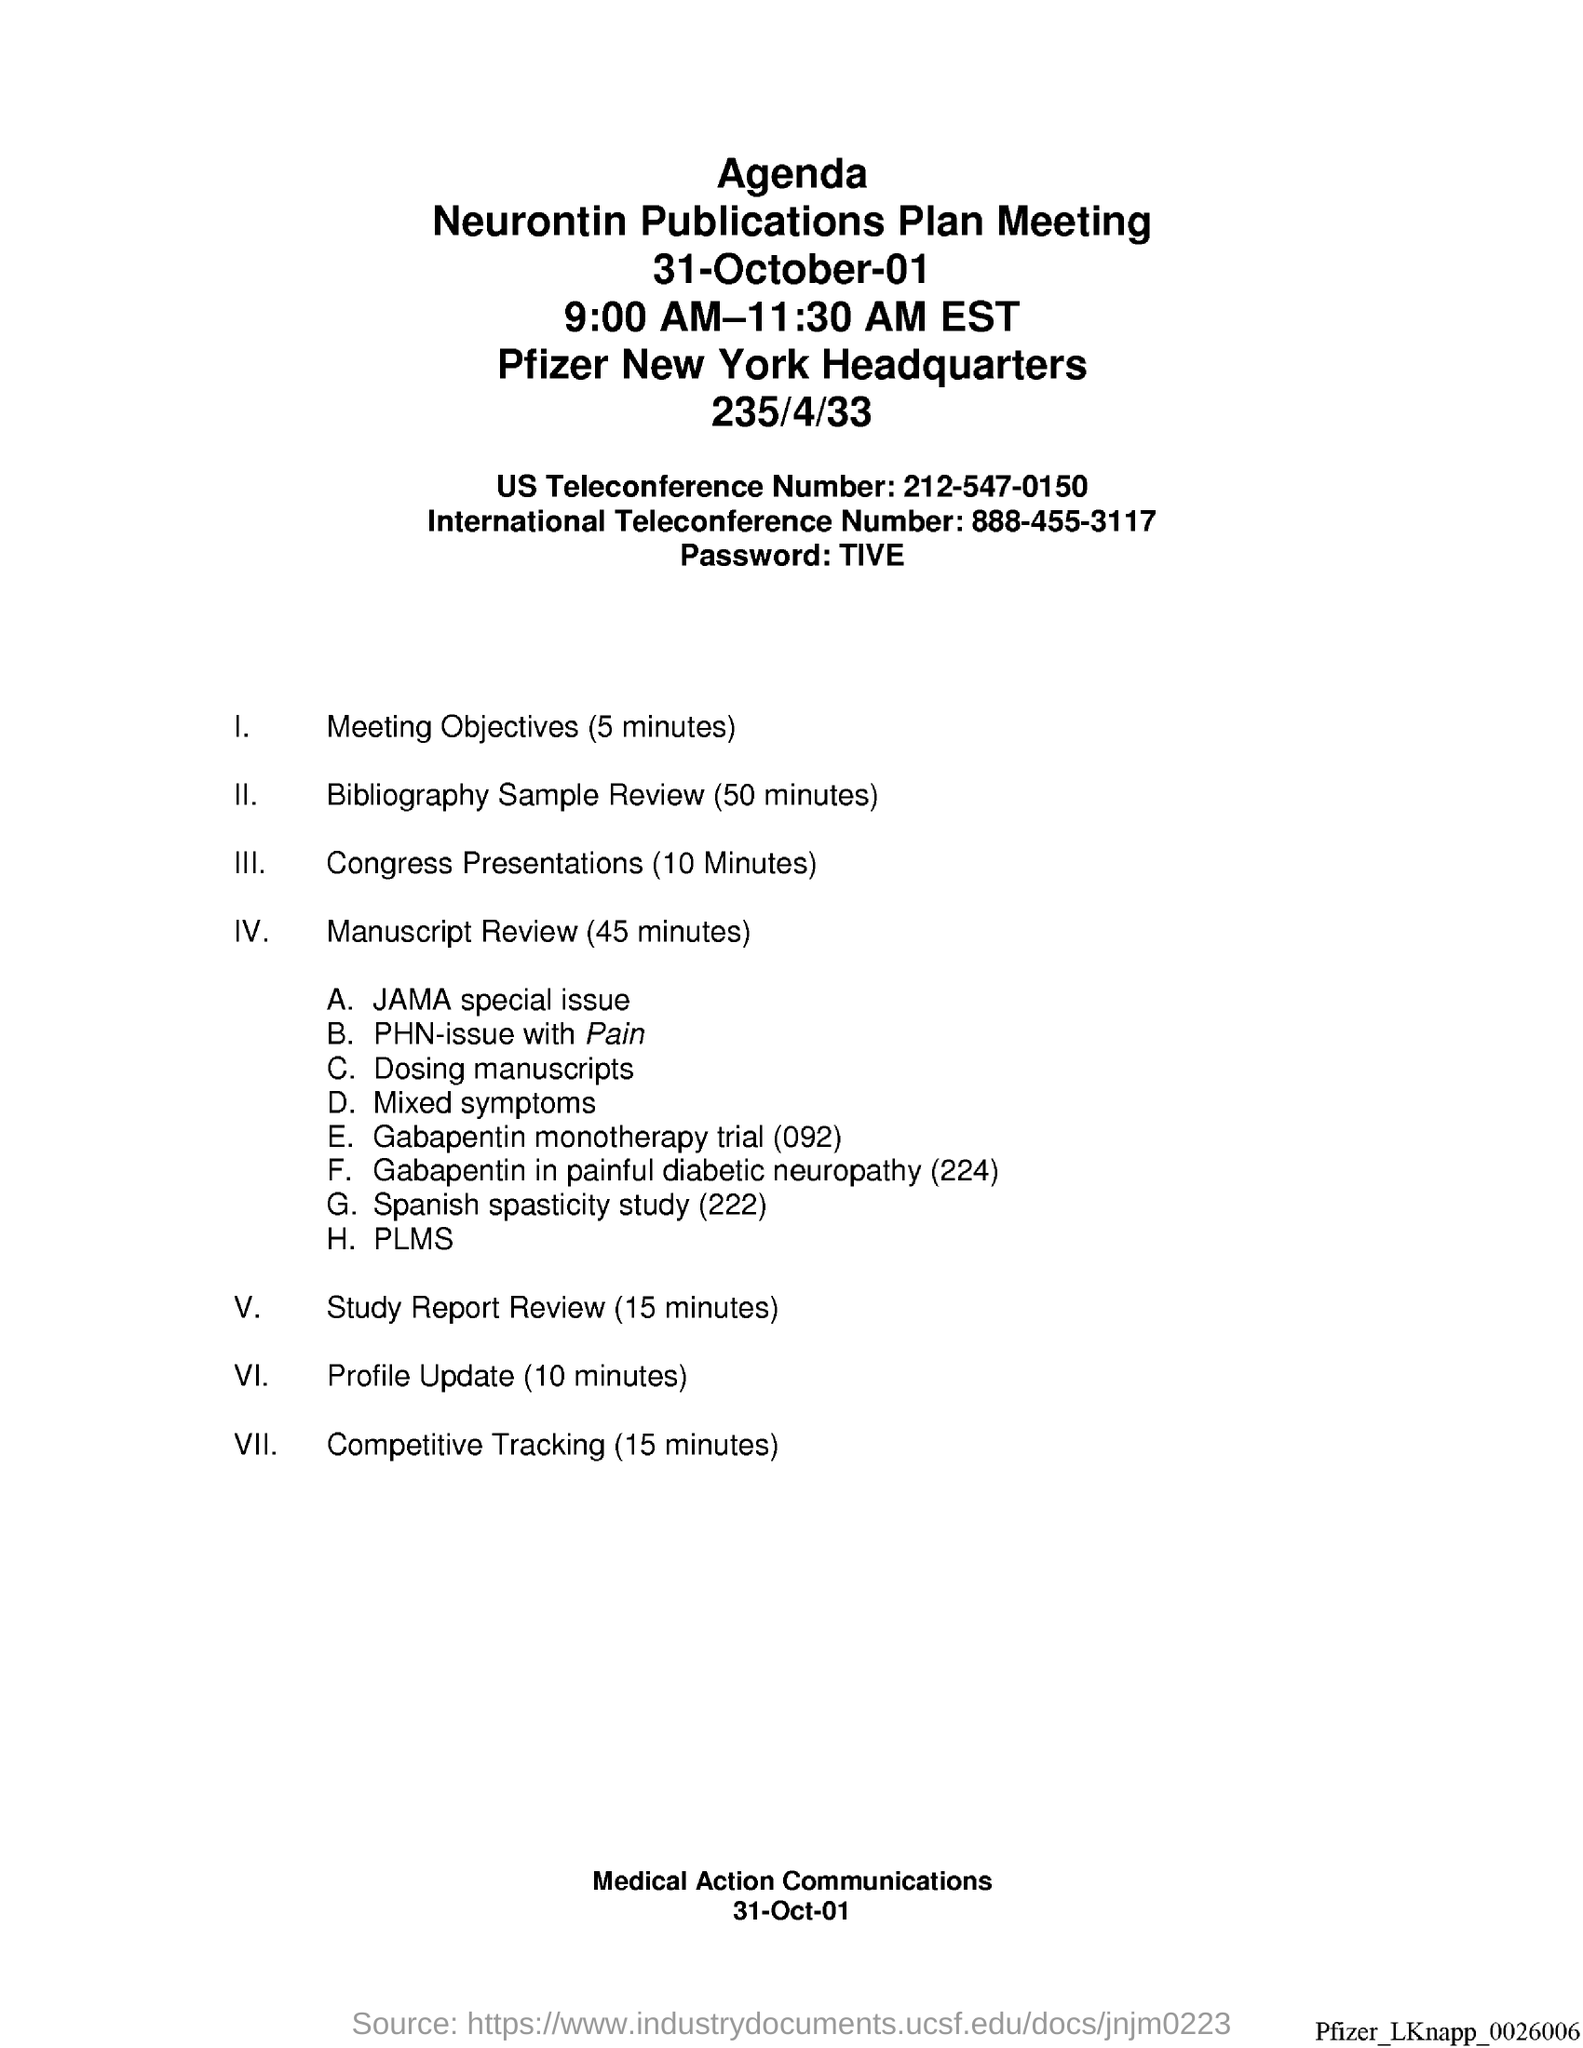Highlight a few significant elements in this photo. The US teleconference number is 212-547-0150. The date at the bottom of the page is 31st October 2001. The international teleconference number is 888-455-3117. The password is 'TIVE'. 